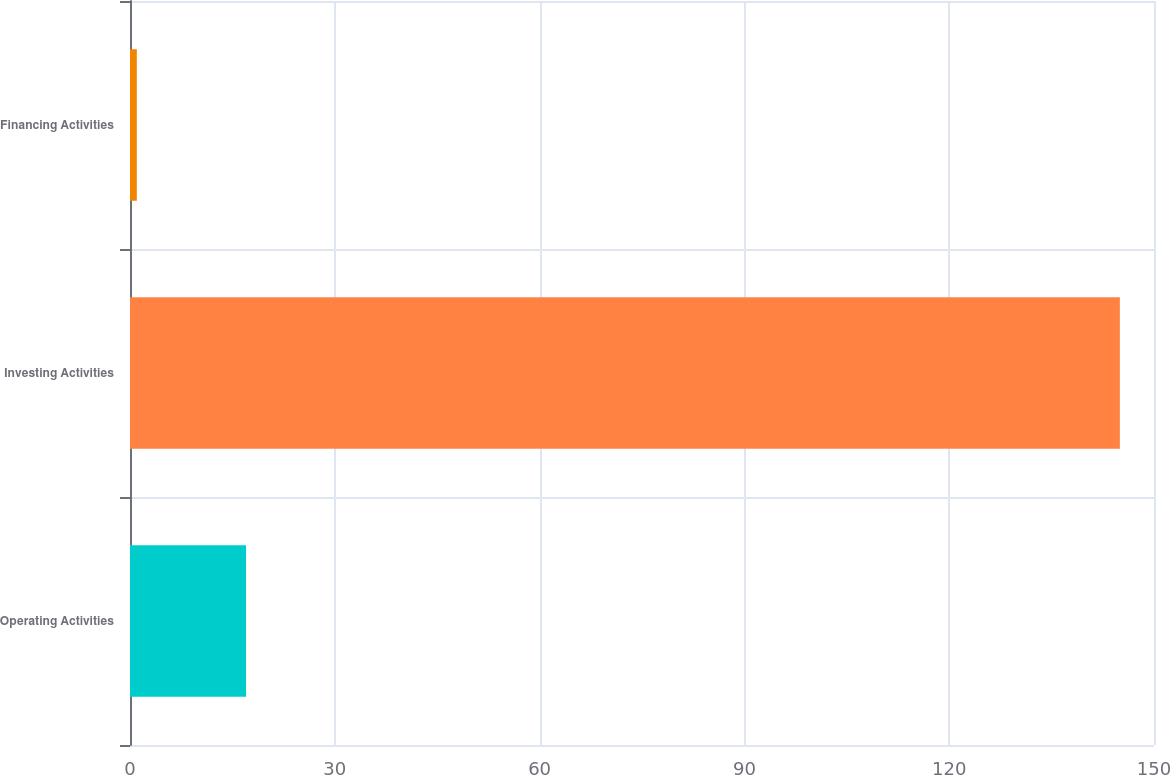Convert chart to OTSL. <chart><loc_0><loc_0><loc_500><loc_500><bar_chart><fcel>Operating Activities<fcel>Investing Activities<fcel>Financing Activities<nl><fcel>17<fcel>145<fcel>1<nl></chart> 